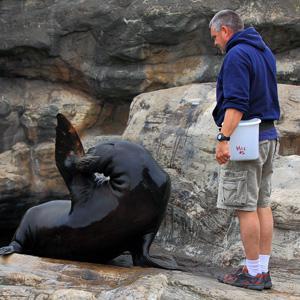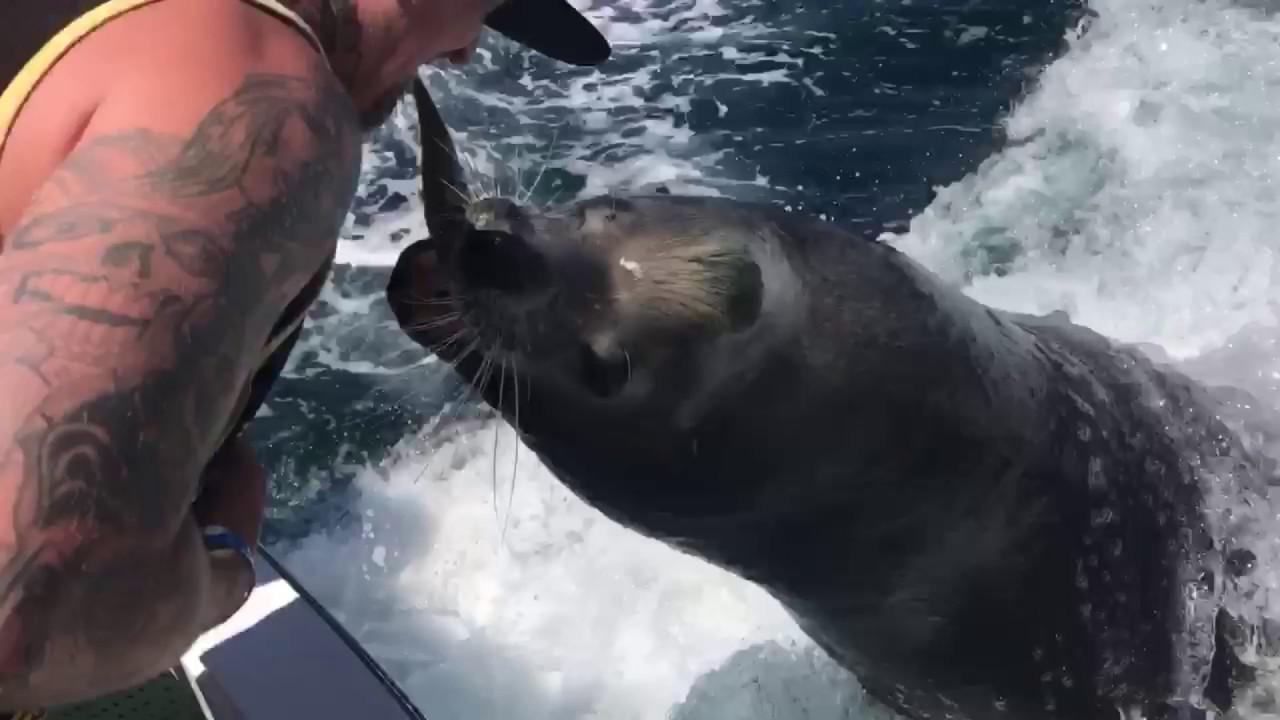The first image is the image on the left, the second image is the image on the right. For the images displayed, is the sentence "A man is holding a silver bucket as at least 3 seals gather around him." factually correct? Answer yes or no. No. The first image is the image on the left, the second image is the image on the right. For the images displayed, is the sentence "In both images, an aquarist is being hugged and kissed by a sea lion." factually correct? Answer yes or no. No. 